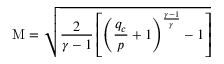<formula> <loc_0><loc_0><loc_500><loc_500>M = { \sqrt { { \frac { 2 } { \gamma - 1 } } \left [ \left ( { \frac { q _ { c } } { p } } + 1 \right ) ^ { \frac { \gamma - 1 } { \gamma } } - 1 \right ] } }</formula> 